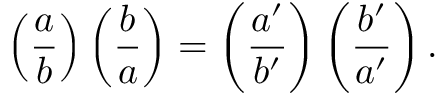<formula> <loc_0><loc_0><loc_500><loc_500>\left ( { \frac { a } { b } } \right ) \left ( { \frac { b } { a } } \right ) = \left ( { \frac { a ^ { \prime } } { b ^ { \prime } } } \right ) \left ( { \frac { b ^ { \prime } } { a ^ { \prime } } } \right ) .</formula> 